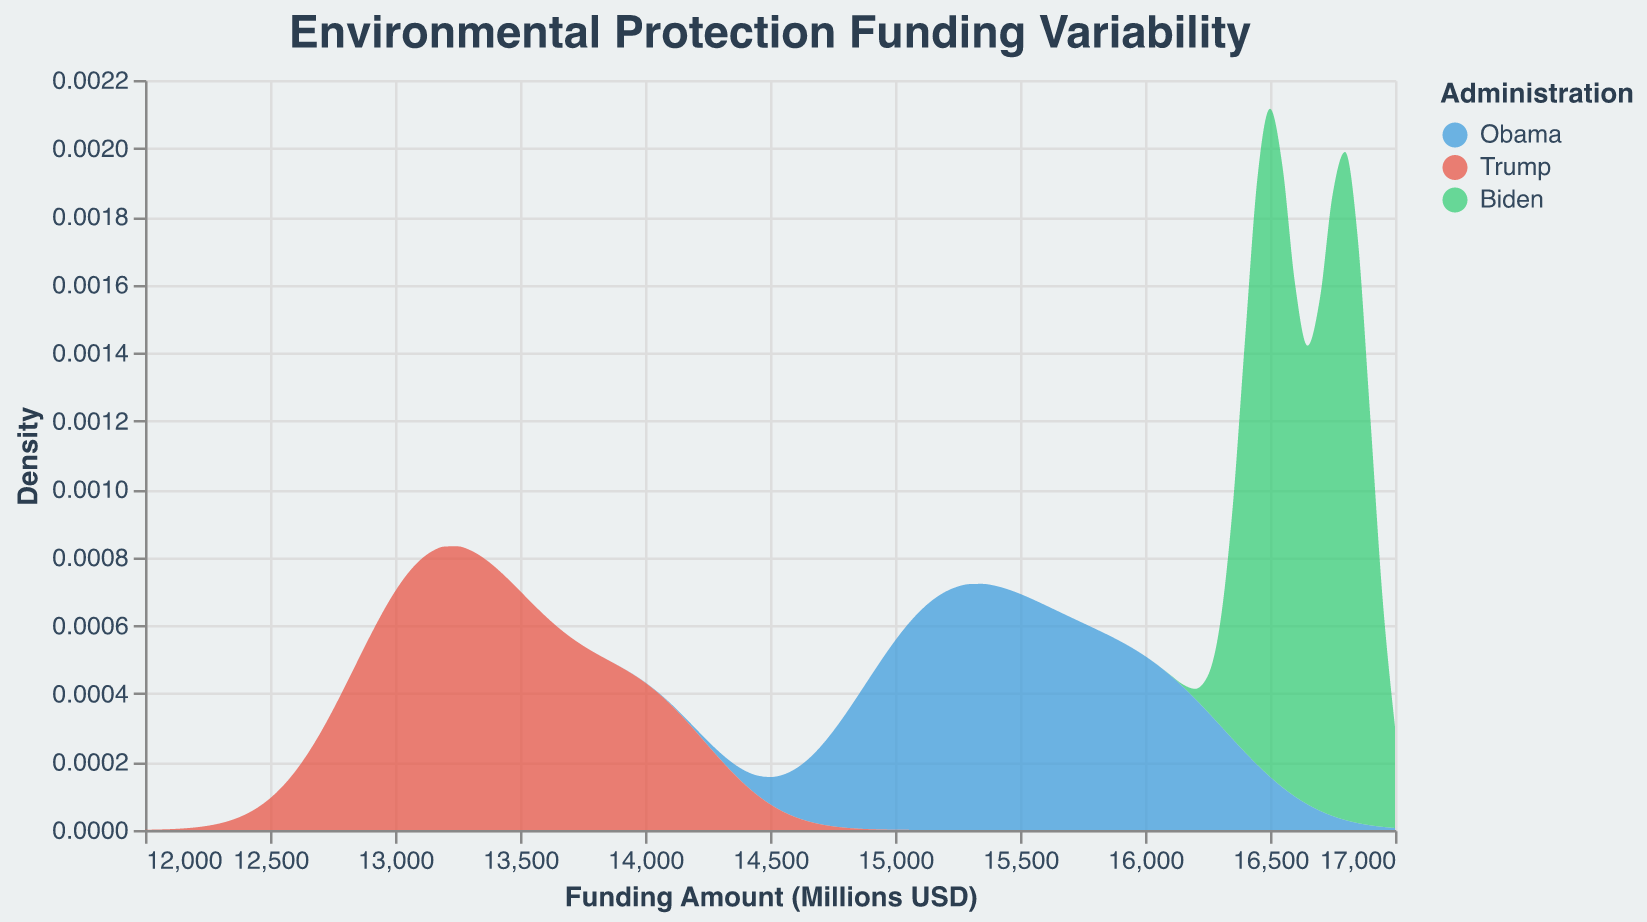What is the title of the plot? The title is located at the top of the plot, displayed in a larger font size and darker color.
Answer: Environmental Protection Funding Variability What is the range of the x-axis (Funding Amount)? The x-axis range can be observed at the bottom of the plot, marked with numeric values starting from 12000 and ending at 17000.
Answer: 12000 to 17000 Which Administration has the highest density value in the plot? The density value is shown on the y-axis. The density area for Biden appears to be the highest, peaking at a higher density compared to Obama and Trump.
Answer: Biden What colors represent the Obama, Trump, and Biden administrations? The colors for each administration are displayed in the legend on the right side of the plot. Obama is represented by blue, Trump by red, and Biden by green.
Answer: Blue for Obama, red for Trump, green for Biden Which Administration shows the lowest funding variability on the plot? Low variability is indicated by a narrower density curve. The Trump administration has the narrowest curve, showing low variability compared to Obama and Biden.
Answer: Trump How does the average funding amount for the Obama administration compare to Trump’s? The Obama administration's density curve is centered around a higher funding amount (~15500) compared to Trump’s (~13500), reflecting Obama's higher average funding.
Answer: Higher What is the peak funding amount for the Trump administration based on the density plot? The peak funding amount can be identified by finding the highest point of the density curve for Trump, which is approximately 13500.
Answer: 13500 How does the density for Biden’s administration change over the funding amount range? Biden's density starts lower, increases sharply, and peaks around 16500 before dropping off, indicating concentrated funding around this amount.
Answer: Peaks around 16500 Do the density plots for any two administrations overlap? Overlap is observed where the density areas of different administrations share the same region. Obama's and Biden's plots overlap slightly between 15500 and 16000.
Answer: Yes, Obama and Biden Which administration's funding amounts have the widest spread? The widest spread is indicated by the broadest density area. Obama's density area spans a wider funding range compared to Trump and Biden.
Answer: Obama 